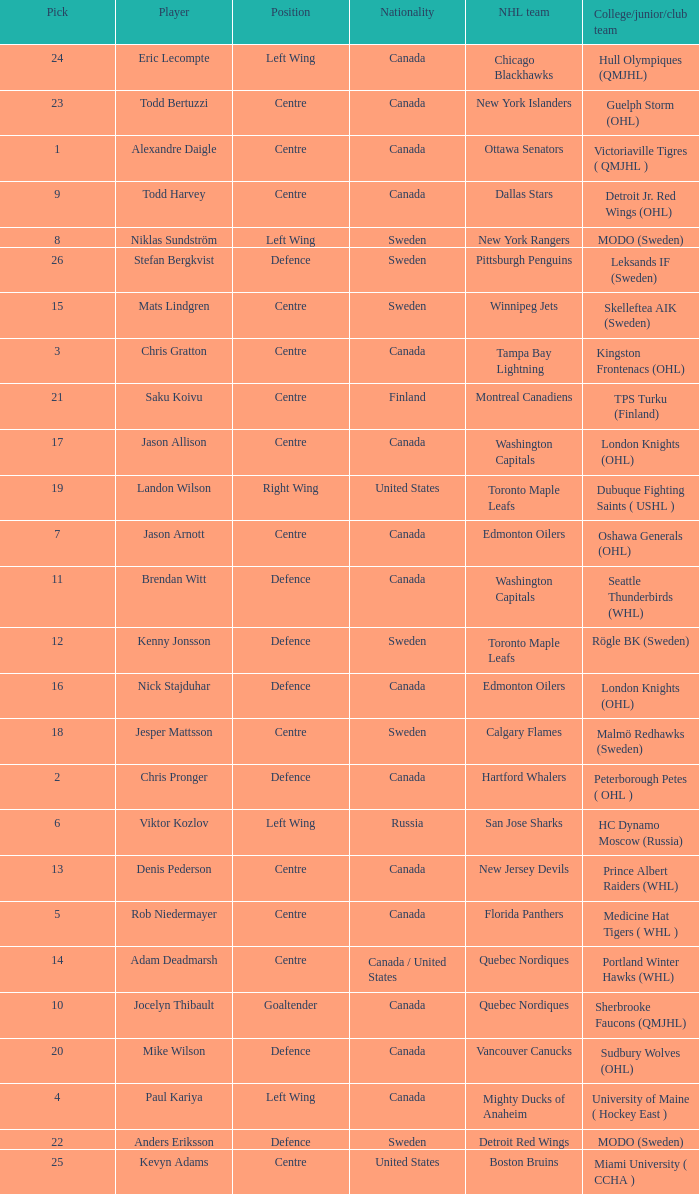What is the college/junior/club team name of player Mats Lindgren? Skelleftea AIK (Sweden). Would you mind parsing the complete table? {'header': ['Pick', 'Player', 'Position', 'Nationality', 'NHL team', 'College/junior/club team'], 'rows': [['24', 'Eric Lecompte', 'Left Wing', 'Canada', 'Chicago Blackhawks', 'Hull Olympiques (QMJHL)'], ['23', 'Todd Bertuzzi', 'Centre', 'Canada', 'New York Islanders', 'Guelph Storm (OHL)'], ['1', 'Alexandre Daigle', 'Centre', 'Canada', 'Ottawa Senators', 'Victoriaville Tigres ( QMJHL )'], ['9', 'Todd Harvey', 'Centre', 'Canada', 'Dallas Stars', 'Detroit Jr. Red Wings (OHL)'], ['8', 'Niklas Sundström', 'Left Wing', 'Sweden', 'New York Rangers', 'MODO (Sweden)'], ['26', 'Stefan Bergkvist', 'Defence', 'Sweden', 'Pittsburgh Penguins', 'Leksands IF (Sweden)'], ['15', 'Mats Lindgren', 'Centre', 'Sweden', 'Winnipeg Jets', 'Skelleftea AIK (Sweden)'], ['3', 'Chris Gratton', 'Centre', 'Canada', 'Tampa Bay Lightning', 'Kingston Frontenacs (OHL)'], ['21', 'Saku Koivu', 'Centre', 'Finland', 'Montreal Canadiens', 'TPS Turku (Finland)'], ['17', 'Jason Allison', 'Centre', 'Canada', 'Washington Capitals', 'London Knights (OHL)'], ['19', 'Landon Wilson', 'Right Wing', 'United States', 'Toronto Maple Leafs', 'Dubuque Fighting Saints ( USHL )'], ['7', 'Jason Arnott', 'Centre', 'Canada', 'Edmonton Oilers', 'Oshawa Generals (OHL)'], ['11', 'Brendan Witt', 'Defence', 'Canada', 'Washington Capitals', 'Seattle Thunderbirds (WHL)'], ['12', 'Kenny Jonsson', 'Defence', 'Sweden', 'Toronto Maple Leafs', 'Rögle BK (Sweden)'], ['16', 'Nick Stajduhar', 'Defence', 'Canada', 'Edmonton Oilers', 'London Knights (OHL)'], ['18', 'Jesper Mattsson', 'Centre', 'Sweden', 'Calgary Flames', 'Malmö Redhawks (Sweden)'], ['2', 'Chris Pronger', 'Defence', 'Canada', 'Hartford Whalers', 'Peterborough Petes ( OHL )'], ['6', 'Viktor Kozlov', 'Left Wing', 'Russia', 'San Jose Sharks', 'HC Dynamo Moscow (Russia)'], ['13', 'Denis Pederson', 'Centre', 'Canada', 'New Jersey Devils', 'Prince Albert Raiders (WHL)'], ['5', 'Rob Niedermayer', 'Centre', 'Canada', 'Florida Panthers', 'Medicine Hat Tigers ( WHL )'], ['14', 'Adam Deadmarsh', 'Centre', 'Canada / United States', 'Quebec Nordiques', 'Portland Winter Hawks (WHL)'], ['10', 'Jocelyn Thibault', 'Goaltender', 'Canada', 'Quebec Nordiques', 'Sherbrooke Faucons (QMJHL)'], ['20', 'Mike Wilson', 'Defence', 'Canada', 'Vancouver Canucks', 'Sudbury Wolves (OHL)'], ['4', 'Paul Kariya', 'Left Wing', 'Canada', 'Mighty Ducks of Anaheim', 'University of Maine ( Hockey East )'], ['22', 'Anders Eriksson', 'Defence', 'Sweden', 'Detroit Red Wings', 'MODO (Sweden)'], ['25', 'Kevyn Adams', 'Centre', 'United States', 'Boston Bruins', 'Miami University ( CCHA )']]} 